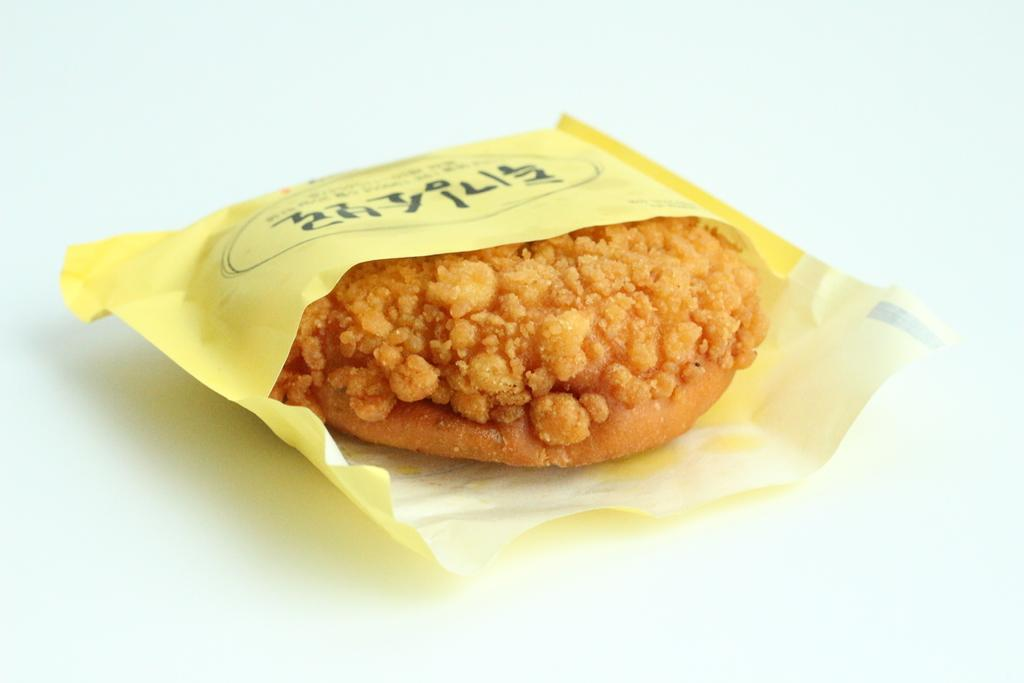What is present in the image that contains a food item? There is a packet in the image that contains a food item. Where is the packet located in the image? The packet is placed on a surface in the image. What type of snail can be seen wearing a badge in the image? There is no snail or badge present in the image. 